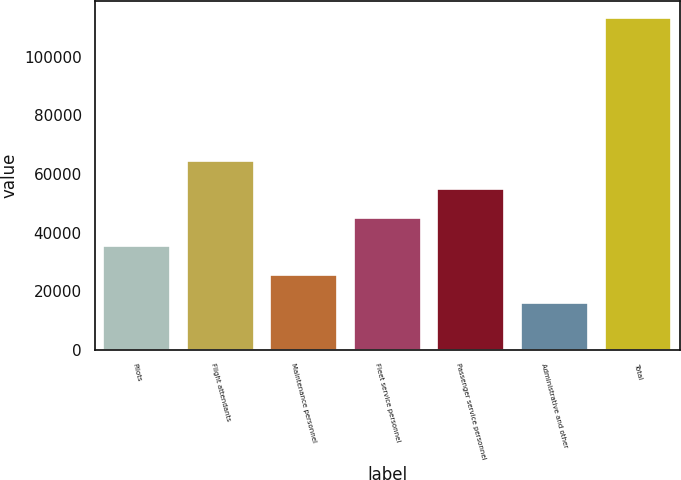Convert chart. <chart><loc_0><loc_0><loc_500><loc_500><bar_chart><fcel>Pilots<fcel>Flight attendants<fcel>Maintenance personnel<fcel>Fleet service personnel<fcel>Passenger service personnel<fcel>Administrative and other<fcel>Total<nl><fcel>35300<fcel>64550<fcel>25550<fcel>45050<fcel>54800<fcel>15800<fcel>113300<nl></chart> 